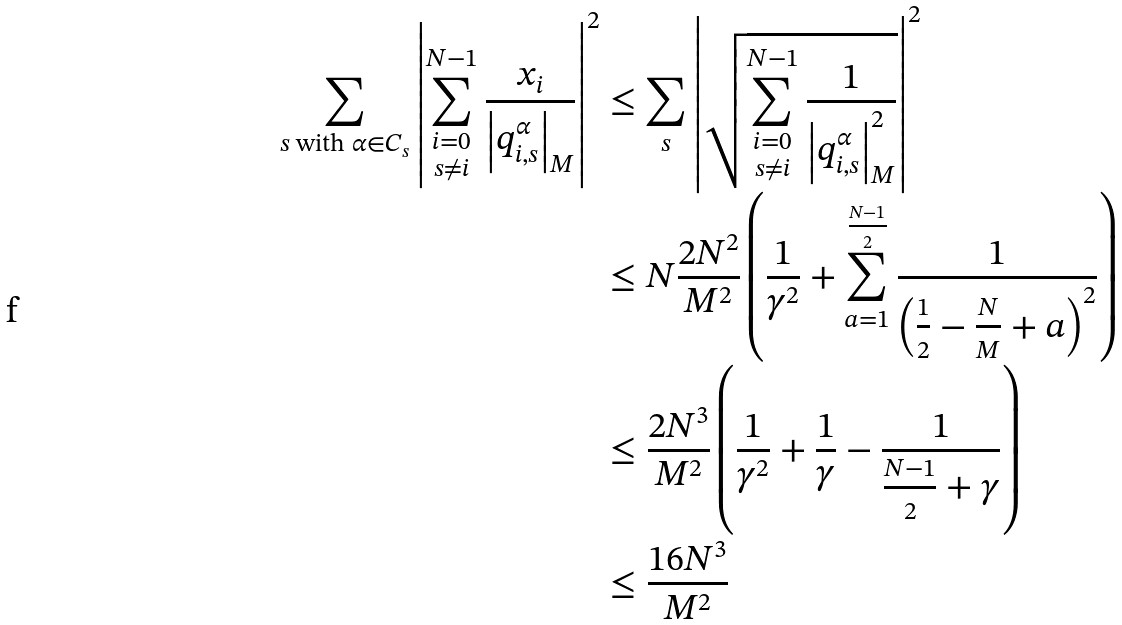Convert formula to latex. <formula><loc_0><loc_0><loc_500><loc_500>\sum _ { s \text { with } \alpha \in C _ { s } } \left | \sum _ { \substack { i = 0 \\ s \neq i } } ^ { N - 1 } \frac { x _ { i } } { \left | q _ { i , s } ^ { \alpha } \right | _ { M } } \right | ^ { 2 } & \leq \sum _ { s } \left | \sqrt { \sum _ { \substack { i = 0 \\ s \neq i } } ^ { N - 1 } \frac { 1 } { \left | q _ { i , s } ^ { \alpha } \right | _ { M } ^ { 2 } } } \right | ^ { 2 } \\ & \leq N \frac { 2 N ^ { 2 } } { M ^ { 2 } } \left ( \frac { 1 } { \gamma ^ { 2 } } + \sum _ { a = 1 } ^ { \frac { N - 1 } { 2 } } \frac { 1 } { \left ( \frac { 1 } { 2 } - \frac { N } { M } + a \right ) ^ { 2 } } \right ) \\ & \leq \frac { 2 N ^ { 3 } } { M ^ { 2 } } \left ( \frac { 1 } { \gamma ^ { 2 } } + \frac { 1 } { \gamma } - \frac { 1 } { \frac { N - 1 } { 2 } + \gamma } \right ) \\ & \leq \frac { 1 6 N ^ { 3 } } { M ^ { 2 } }</formula> 